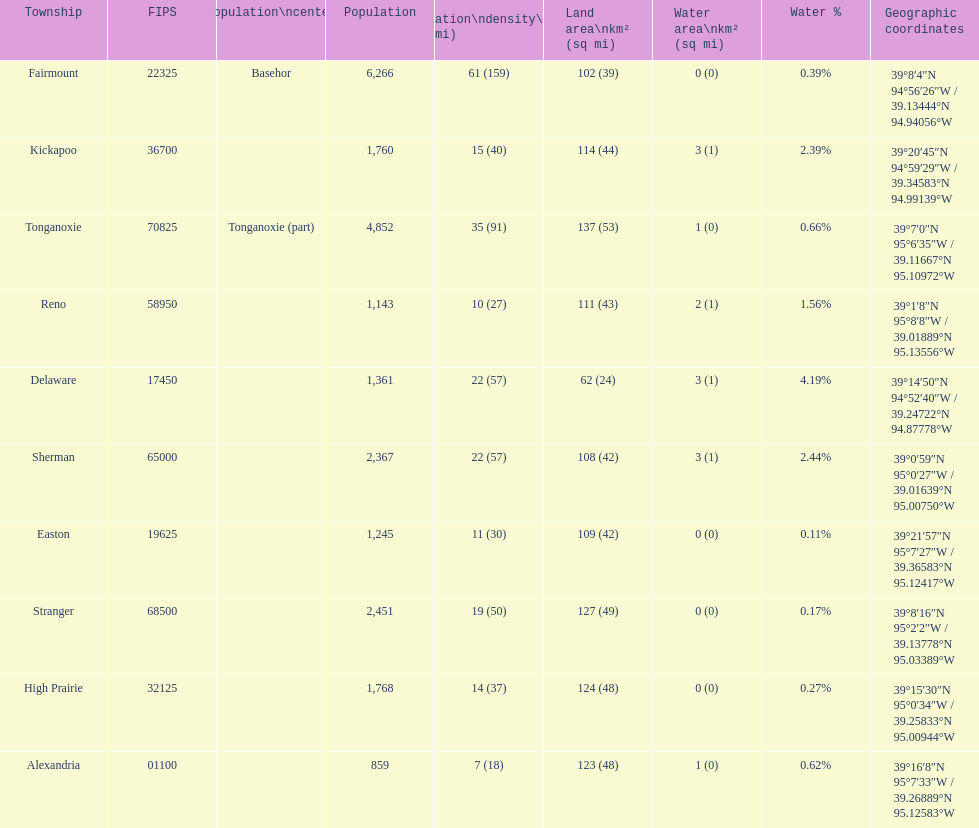What township has the largest population? Fairmount. 